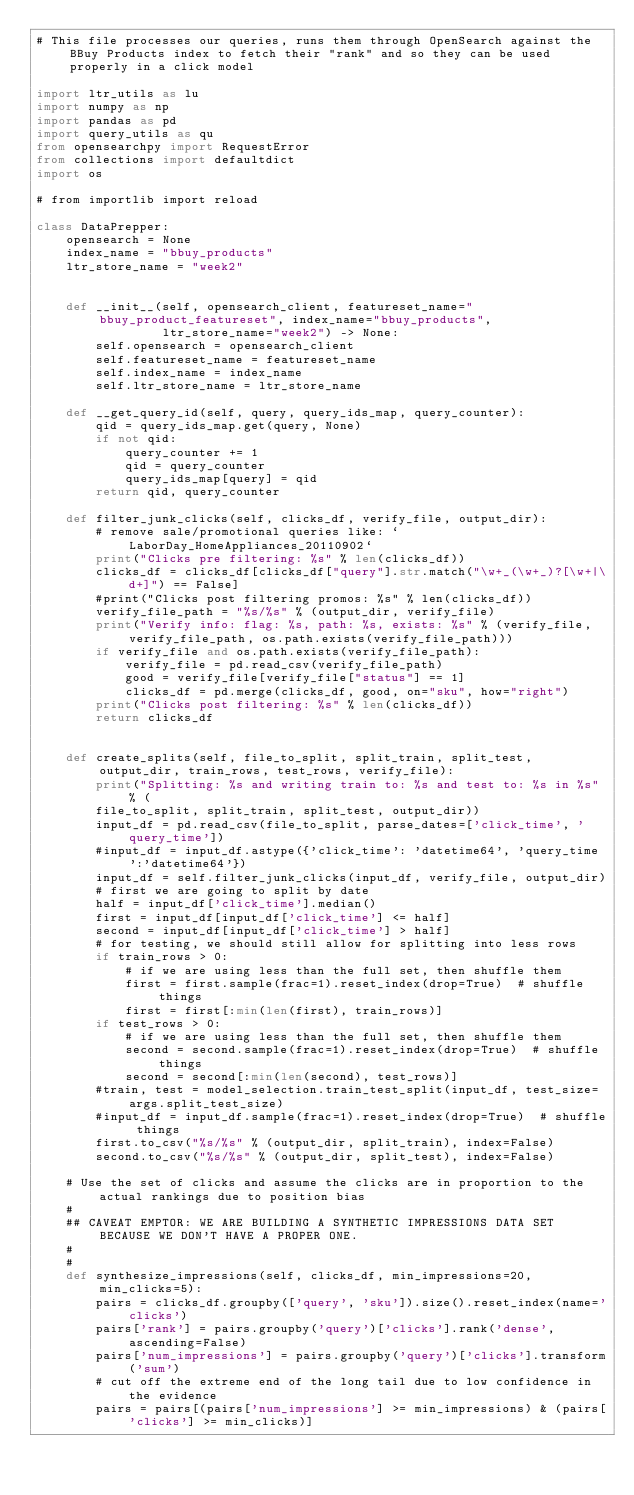Convert code to text. <code><loc_0><loc_0><loc_500><loc_500><_Python_># This file processes our queries, runs them through OpenSearch against the BBuy Products index to fetch their "rank" and so they can be used properly in a click model

import ltr_utils as lu
import numpy as np
import pandas as pd
import query_utils as qu
from opensearchpy import RequestError
from collections import defaultdict
import os

# from importlib import reload

class DataPrepper:
    opensearch = None
    index_name = "bbuy_products"
    ltr_store_name = "week2"


    def __init__(self, opensearch_client, featureset_name="bbuy_product_featureset", index_name="bbuy_products",
                 ltr_store_name="week2") -> None:
        self.opensearch = opensearch_client
        self.featureset_name = featureset_name
        self.index_name = index_name
        self.ltr_store_name = ltr_store_name

    def __get_query_id(self, query, query_ids_map, query_counter):
        qid = query_ids_map.get(query, None)
        if not qid:
            query_counter += 1
            qid = query_counter
            query_ids_map[query] = qid
        return qid, query_counter

    def filter_junk_clicks(self, clicks_df, verify_file, output_dir):
        # remove sale/promotional queries like: `LaborDay_HomeAppliances_20110902`
        print("Clicks pre filtering: %s" % len(clicks_df))
        clicks_df = clicks_df[clicks_df["query"].str.match("\w+_(\w+_)?[\w+|\d+]") == False]
        #print("Clicks post filtering promos: %s" % len(clicks_df))
        verify_file_path = "%s/%s" % (output_dir, verify_file)
        print("Verify info: flag: %s, path: %s, exists: %s" % (verify_file, verify_file_path, os.path.exists(verify_file_path)))
        if verify_file and os.path.exists(verify_file_path):
            verify_file = pd.read_csv(verify_file_path)
            good = verify_file[verify_file["status"] == 1]
            clicks_df = pd.merge(clicks_df, good, on="sku", how="right")
        print("Clicks post filtering: %s" % len(clicks_df))
        return clicks_df


    def create_splits(self, file_to_split, split_train, split_test, output_dir, train_rows, test_rows, verify_file):
        print("Splitting: %s and writing train to: %s and test to: %s in %s" % (
        file_to_split, split_train, split_test, output_dir))
        input_df = pd.read_csv(file_to_split, parse_dates=['click_time', 'query_time'])
        #input_df = input_df.astype({'click_time': 'datetime64', 'query_time':'datetime64'})
        input_df = self.filter_junk_clicks(input_df, verify_file, output_dir)
        # first we are going to split by date
        half = input_df['click_time'].median()
        first = input_df[input_df['click_time'] <= half]
        second = input_df[input_df['click_time'] > half]
        # for testing, we should still allow for splitting into less rows
        if train_rows > 0:
            # if we are using less than the full set, then shuffle them
            first = first.sample(frac=1).reset_index(drop=True)  # shuffle things
            first = first[:min(len(first), train_rows)]
        if test_rows > 0:
            # if we are using less than the full set, then shuffle them
            second = second.sample(frac=1).reset_index(drop=True)  # shuffle things
            second = second[:min(len(second), test_rows)]
        #train, test = model_selection.train_test_split(input_df, test_size=args.split_test_size)
        #input_df = input_df.sample(frac=1).reset_index(drop=True)  # shuffle things
        first.to_csv("%s/%s" % (output_dir, split_train), index=False)
        second.to_csv("%s/%s" % (output_dir, split_test), index=False)

    # Use the set of clicks and assume the clicks are in proportion to the actual rankings due to position bias
    #
    ## CAVEAT EMPTOR: WE ARE BUILDING A SYNTHETIC IMPRESSIONS DATA SET BECAUSE WE DON'T HAVE A PROPER ONE.
    #
    #
    def synthesize_impressions(self, clicks_df, min_impressions=20, min_clicks=5):
        pairs = clicks_df.groupby(['query', 'sku']).size().reset_index(name='clicks')
        pairs['rank'] = pairs.groupby('query')['clicks'].rank('dense', ascending=False)
        pairs['num_impressions'] = pairs.groupby('query')['clicks'].transform('sum')
        # cut off the extreme end of the long tail due to low confidence in the evidence
        pairs = pairs[(pairs['num_impressions'] >= min_impressions) & (pairs['clicks'] >= min_clicks)]
</code> 